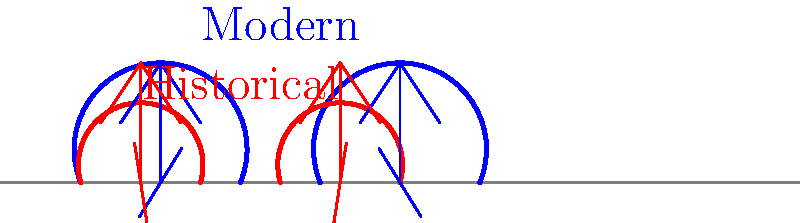Analyze the gait patterns illustrated in the diagram. How does the stride length of individuals wearing historical footwear compare to those wearing modern shoes, and what implications might this have for the subjects in your documentary about historical artifacts? 1. Observe the diagram: The blue lines and figures represent modern shoe gait, while the red lines and figures represent historical shoe gait.

2. Compare stride lengths: The distance between steps for the modern gait (blue) is noticeably longer than for the historical gait (red).

3. Analyze step height: The modern gait shows a higher arc, indicating greater foot clearance from the ground.

4. Consider historical footwear: Historical shoes often had less cushioning and support, leading to shorter, more frequent steps to maintain balance and reduce impact.

5. Implications for documentary subjects:
   a) Movement efficiency: Subjects in historical footwear likely expended more energy while walking.
   b) Speed: Shorter strides suggest slower overall movement in historical settings.
   c) Posture and balance: Different gait patterns imply adjustments in body posture and balance.
   d) Daily life impact: These differences would affect how people moved and worked in historical contexts.

6. Documentary considerations:
   a) Visualize movement differences in reenactments.
   b) Explore how footwear influenced historical activities and occupations.
   c) Discuss the evolution of shoe design and its impact on human biomechanics.

7. Mathematical representation: If we define stride length as $S$ and assume it's proportional to leg length $L$ and a coefficient $k$ dependent on shoe type, we can express it as:

   $$S = k \cdot L$$

   Where $k_{modern} > k_{historical}$, illustrating the longer stride of modern footwear.
Answer: Historical footwear results in shorter stride length, impacting movement efficiency, speed, and daily activities in historical contexts. 